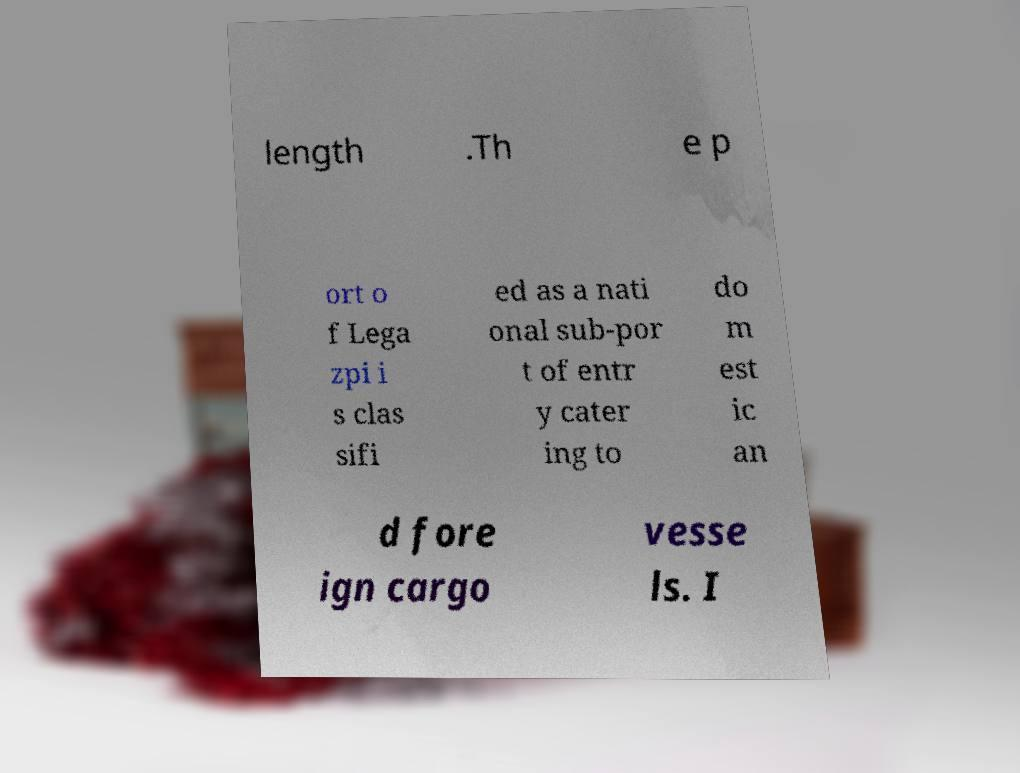Can you accurately transcribe the text from the provided image for me? length .Th e p ort o f Lega zpi i s clas sifi ed as a nati onal sub-por t of entr y cater ing to do m est ic an d fore ign cargo vesse ls. I 